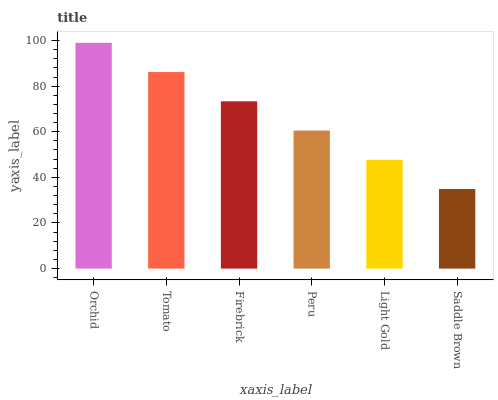Is Saddle Brown the minimum?
Answer yes or no. Yes. Is Orchid the maximum?
Answer yes or no. Yes. Is Tomato the minimum?
Answer yes or no. No. Is Tomato the maximum?
Answer yes or no. No. Is Orchid greater than Tomato?
Answer yes or no. Yes. Is Tomato less than Orchid?
Answer yes or no. Yes. Is Tomato greater than Orchid?
Answer yes or no. No. Is Orchid less than Tomato?
Answer yes or no. No. Is Firebrick the high median?
Answer yes or no. Yes. Is Peru the low median?
Answer yes or no. Yes. Is Peru the high median?
Answer yes or no. No. Is Firebrick the low median?
Answer yes or no. No. 